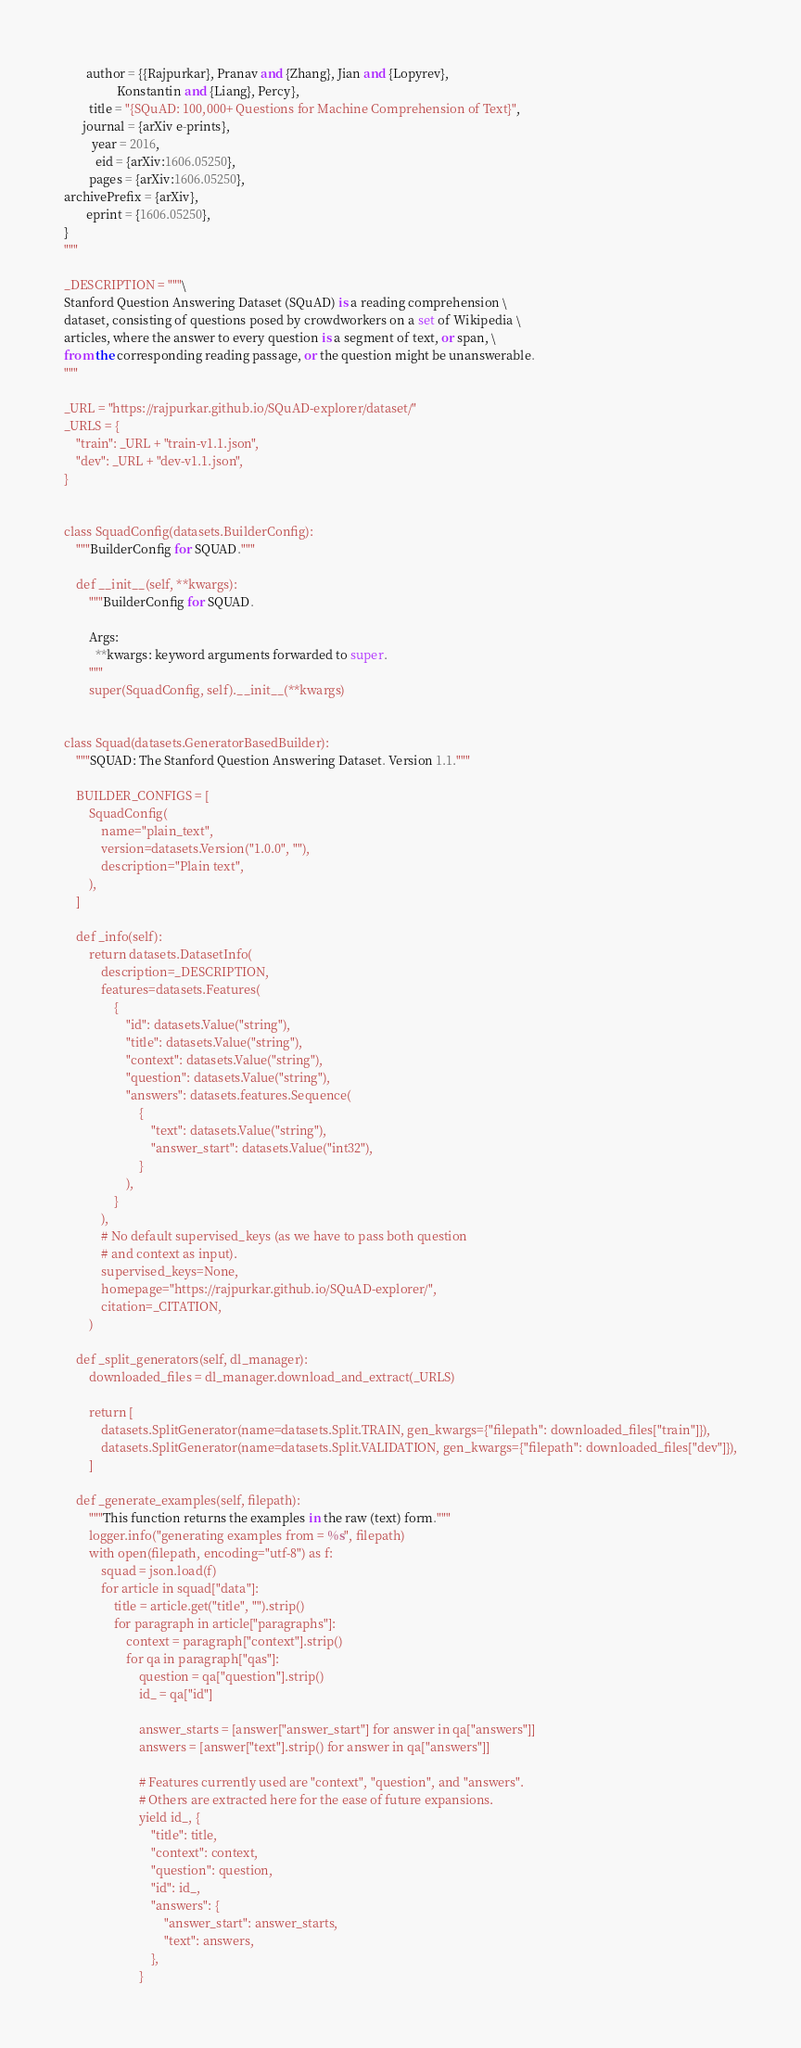<code> <loc_0><loc_0><loc_500><loc_500><_Python_>       author = {{Rajpurkar}, Pranav and {Zhang}, Jian and {Lopyrev},
                 Konstantin and {Liang}, Percy},
        title = "{SQuAD: 100,000+ Questions for Machine Comprehension of Text}",
      journal = {arXiv e-prints},
         year = 2016,
          eid = {arXiv:1606.05250},
        pages = {arXiv:1606.05250},
archivePrefix = {arXiv},
       eprint = {1606.05250},
}
"""

_DESCRIPTION = """\
Stanford Question Answering Dataset (SQuAD) is a reading comprehension \
dataset, consisting of questions posed by crowdworkers on a set of Wikipedia \
articles, where the answer to every question is a segment of text, or span, \
from the corresponding reading passage, or the question might be unanswerable.
"""

_URL = "https://rajpurkar.github.io/SQuAD-explorer/dataset/"
_URLS = {
    "train": _URL + "train-v1.1.json",
    "dev": _URL + "dev-v1.1.json",
}


class SquadConfig(datasets.BuilderConfig):
    """BuilderConfig for SQUAD."""

    def __init__(self, **kwargs):
        """BuilderConfig for SQUAD.

        Args:
          **kwargs: keyword arguments forwarded to super.
        """
        super(SquadConfig, self).__init__(**kwargs)


class Squad(datasets.GeneratorBasedBuilder):
    """SQUAD: The Stanford Question Answering Dataset. Version 1.1."""

    BUILDER_CONFIGS = [
        SquadConfig(
            name="plain_text",
            version=datasets.Version("1.0.0", ""),
            description="Plain text",
        ),
    ]

    def _info(self):
        return datasets.DatasetInfo(
            description=_DESCRIPTION,
            features=datasets.Features(
                {
                    "id": datasets.Value("string"),
                    "title": datasets.Value("string"),
                    "context": datasets.Value("string"),
                    "question": datasets.Value("string"),
                    "answers": datasets.features.Sequence(
                        {
                            "text": datasets.Value("string"),
                            "answer_start": datasets.Value("int32"),
                        }
                    ),
                }
            ),
            # No default supervised_keys (as we have to pass both question
            # and context as input).
            supervised_keys=None,
            homepage="https://rajpurkar.github.io/SQuAD-explorer/",
            citation=_CITATION,
        )

    def _split_generators(self, dl_manager):
        downloaded_files = dl_manager.download_and_extract(_URLS)

        return [
            datasets.SplitGenerator(name=datasets.Split.TRAIN, gen_kwargs={"filepath": downloaded_files["train"]}),
            datasets.SplitGenerator(name=datasets.Split.VALIDATION, gen_kwargs={"filepath": downloaded_files["dev"]}),
        ]

    def _generate_examples(self, filepath):
        """This function returns the examples in the raw (text) form."""
        logger.info("generating examples from = %s", filepath)
        with open(filepath, encoding="utf-8") as f:
            squad = json.load(f)
            for article in squad["data"]:
                title = article.get("title", "").strip()
                for paragraph in article["paragraphs"]:
                    context = paragraph["context"].strip()
                    for qa in paragraph["qas"]:
                        question = qa["question"].strip()
                        id_ = qa["id"]

                        answer_starts = [answer["answer_start"] for answer in qa["answers"]]
                        answers = [answer["text"].strip() for answer in qa["answers"]]

                        # Features currently used are "context", "question", and "answers".
                        # Others are extracted here for the ease of future expansions.
                        yield id_, {
                            "title": title,
                            "context": context,
                            "question": question,
                            "id": id_,
                            "answers": {
                                "answer_start": answer_starts,
                                "text": answers,
                            },
                        }</code> 